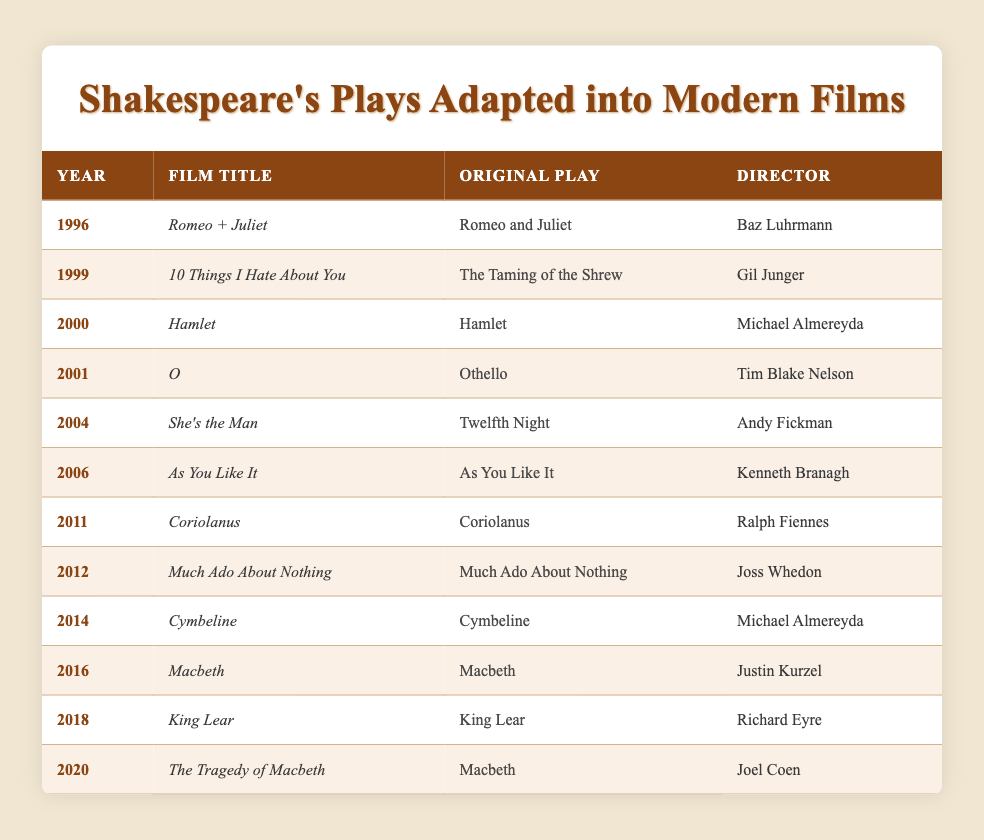What year was "O" released? The table lists "O" under the Year column, which indicates it was released in 2001.
Answer: 2001 Who directed "Much Ado About Nothing"? The Film Title "Much Ado About Nothing" is associated with the Director column listing Joss Whedon as the director.
Answer: Joss Whedon How many films based on Shakespeare's plays were released in the 2010s? From the table, the films in the 2010s are "Coriolanus" (2011), "Much Ado About Nothing" (2012), and "The Tragedy of Macbeth" (2020). Thus, there are three films in total.
Answer: 3 Is "Macbeth" adapted into films by different directors? The original play "Macbeth" appears twice in the table with two different films: "Macbeth" directed by Justin Kurzel in 2016 and "The Tragedy of Macbeth" directed by Joel Coen in 2020, confirming that it has been adapted by different directors.
Answer: Yes What films were released after "10 Things I Hate About You"? The films released after 1999 (the year "10 Things I Hate About You" came out) include "Hamlet" (2000), "O" (2001), "She's the Man" (2004), "As You Like It" (2006), "Coriolanus" (2011), "Much Ado About Nothing" (2012), "Cymbeline" (2014), "Macbeth" (2016), "King Lear" (2018), and "The Tragedy of Macbeth" (2020). This reflects a total of ten films.
Answer: 10 